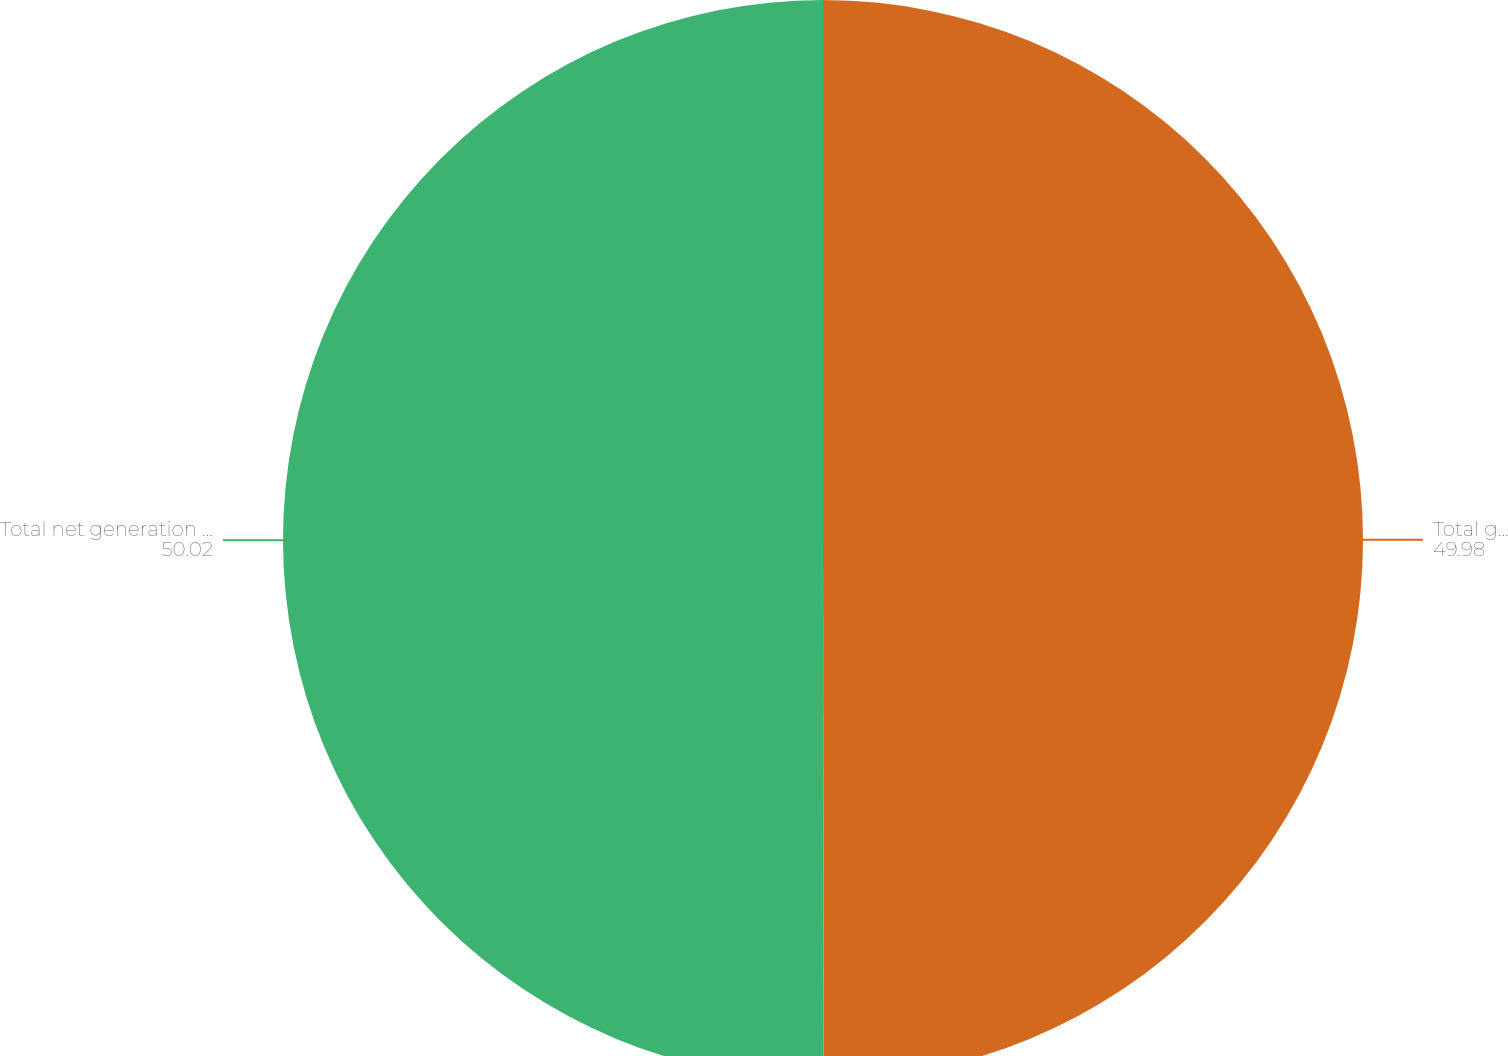<chart> <loc_0><loc_0><loc_500><loc_500><pie_chart><fcel>Total generation capacity (i)<fcel>Total net generation capacity<nl><fcel>49.98%<fcel>50.02%<nl></chart> 